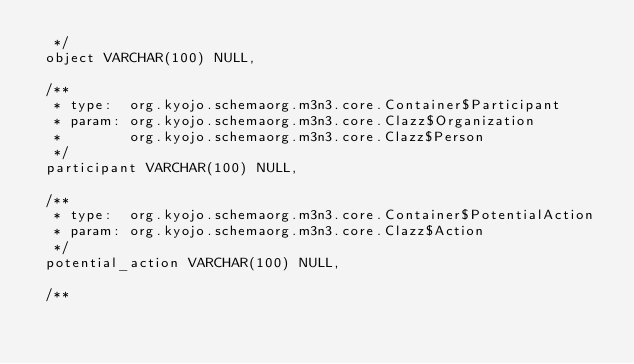Convert code to text. <code><loc_0><loc_0><loc_500><loc_500><_SQL_>  */
 object VARCHAR(100) NULL,

 /**
  * type:  org.kyojo.schemaorg.m3n3.core.Container$Participant
  * param: org.kyojo.schemaorg.m3n3.core.Clazz$Organization
  *        org.kyojo.schemaorg.m3n3.core.Clazz$Person
  */
 participant VARCHAR(100) NULL,

 /**
  * type:  org.kyojo.schemaorg.m3n3.core.Container$PotentialAction
  * param: org.kyojo.schemaorg.m3n3.core.Clazz$Action
  */
 potential_action VARCHAR(100) NULL,

 /**</code> 